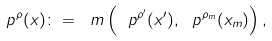<formula> <loc_0><loc_0><loc_500><loc_500>\ p ^ { \rho } ( x ) \colon = \ m \left ( \ p ^ { \rho ^ { \prime } } ( x ^ { \prime } ) , \ p ^ { \rho _ { m } } ( x _ { m } ) \right ) ,</formula> 